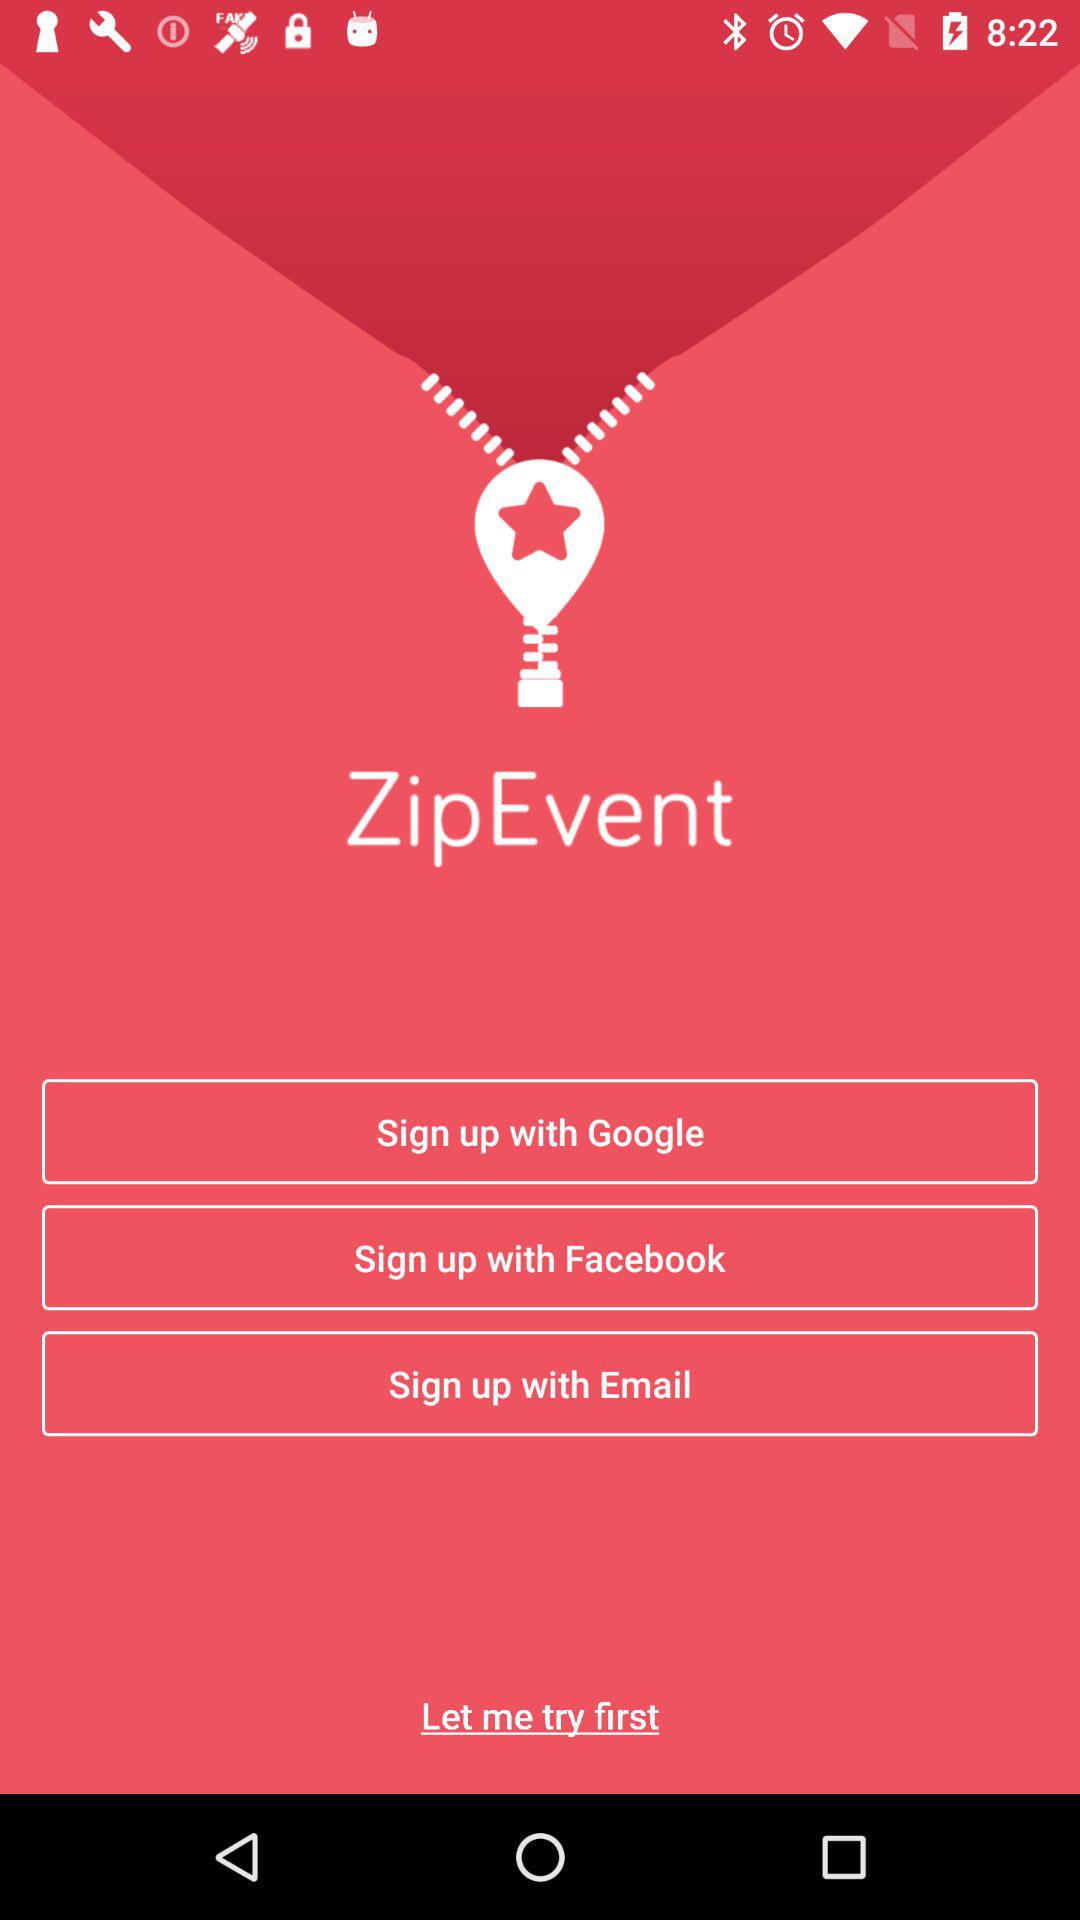What are the different options for signing up? The different options for signing up are "Google", "Facebook" and "Email". 